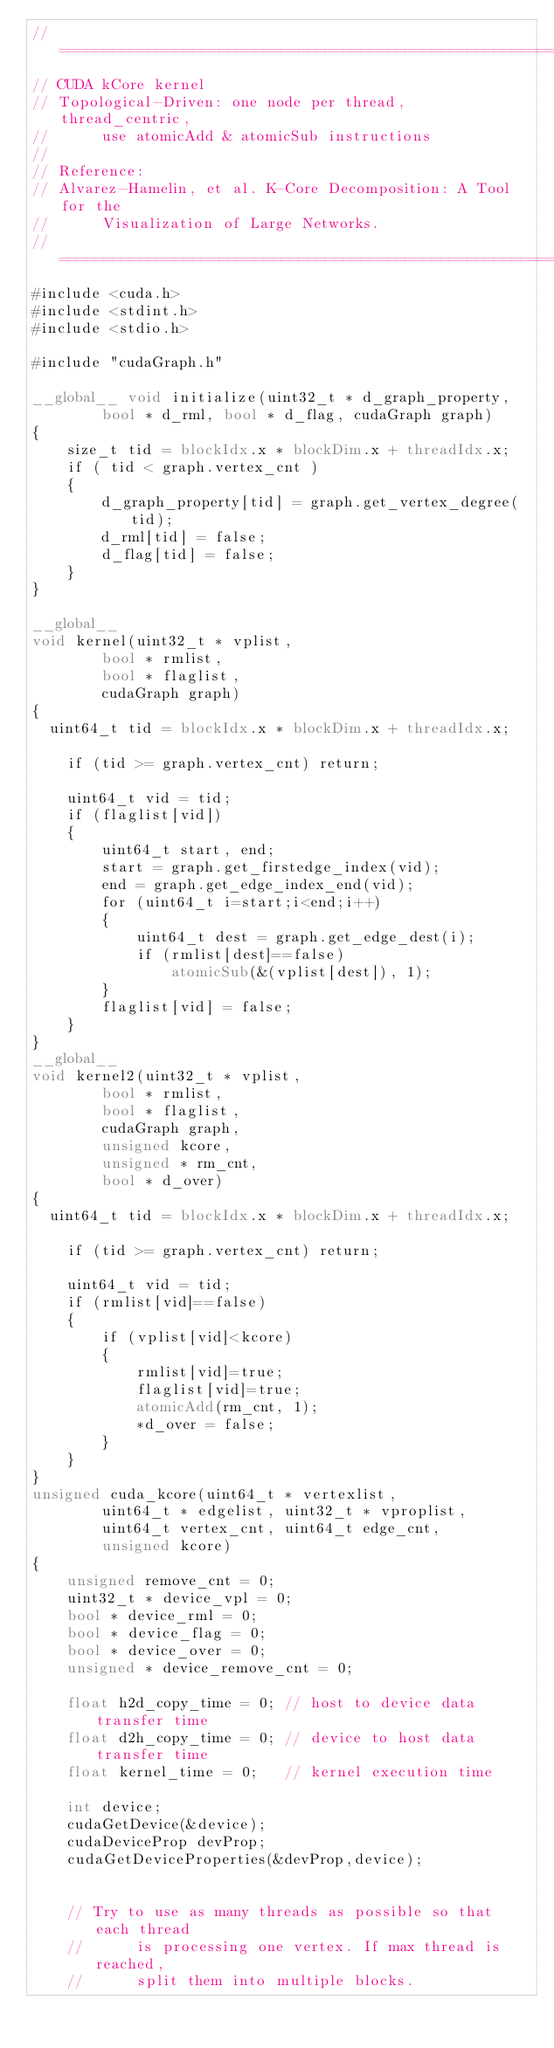<code> <loc_0><loc_0><loc_500><loc_500><_Cuda_>//=================================================================//
// CUDA kCore kernel
// Topological-Driven: one node per thread, thread_centric,
//      use atomicAdd & atomicSub instructions
//
// Reference: 
// Alvarez-Hamelin, et al. K-Core Decomposition: A Tool for the 
//      Visualization of Large Networks.
//=================================================================//
#include <cuda.h>
#include <stdint.h>
#include <stdio.h>

#include "cudaGraph.h"

__global__ void initialize(uint32_t * d_graph_property, 
        bool * d_rml, bool * d_flag, cudaGraph graph)
{
    size_t tid = blockIdx.x * blockDim.x + threadIdx.x;
    if ( tid < graph.vertex_cnt )
    {
        d_graph_property[tid] = graph.get_vertex_degree(tid);
        d_rml[tid] = false;
        d_flag[tid] = false;
    }
}

__global__
void kernel(uint32_t * vplist, 
        bool * rmlist, 
        bool * flaglist, 
        cudaGraph graph) 
{
	uint64_t tid = blockIdx.x * blockDim.x + threadIdx.x;

    if (tid >= graph.vertex_cnt) return;

    uint64_t vid = tid;
    if (flaglist[vid])
    {
        uint64_t start, end;
        start = graph.get_firstedge_index(vid);
        end = graph.get_edge_index_end(vid);
        for (uint64_t i=start;i<end;i++)
        {
            uint64_t dest = graph.get_edge_dest(i);
            if (rmlist[dest]==false)
                atomicSub(&(vplist[dest]), 1);
        }
        flaglist[vid] = false;
    }
}
__global__
void kernel2(uint32_t * vplist, 
        bool * rmlist, 
        bool * flaglist, 
        cudaGraph graph, 
        unsigned kcore, 
        unsigned * rm_cnt, 
        bool * d_over) 
{
	uint64_t tid = blockIdx.x * blockDim.x + threadIdx.x;

    if (tid >= graph.vertex_cnt) return;

    uint64_t vid = tid;
    if (rmlist[vid]==false)
    {
        if (vplist[vid]<kcore)
        {
            rmlist[vid]=true;
            flaglist[vid]=true;
            atomicAdd(rm_cnt, 1);
            *d_over = false;
        }
    }
}
unsigned cuda_kcore(uint64_t * vertexlist,  
        uint64_t * edgelist, uint32_t * vproplist,
        uint64_t vertex_cnt, uint64_t edge_cnt,
        unsigned kcore)
{
    unsigned remove_cnt = 0;
    uint32_t * device_vpl = 0;
    bool * device_rml = 0;
    bool * device_flag = 0;
    bool * device_over = 0;
    unsigned * device_remove_cnt = 0;

    float h2d_copy_time = 0; // host to device data transfer time
    float d2h_copy_time = 0; // device to host data transfer time
    float kernel_time = 0;   // kernel execution time

    int device;
    cudaGetDevice(&device);
    cudaDeviceProp devProp;
    cudaGetDeviceProperties(&devProp,device);


    // Try to use as many threads as possible so that each thread
    //      is processing one vertex. If max thread is reached, 
    //      split them into multiple blocks.</code> 